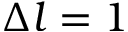<formula> <loc_0><loc_0><loc_500><loc_500>\Delta l = 1</formula> 